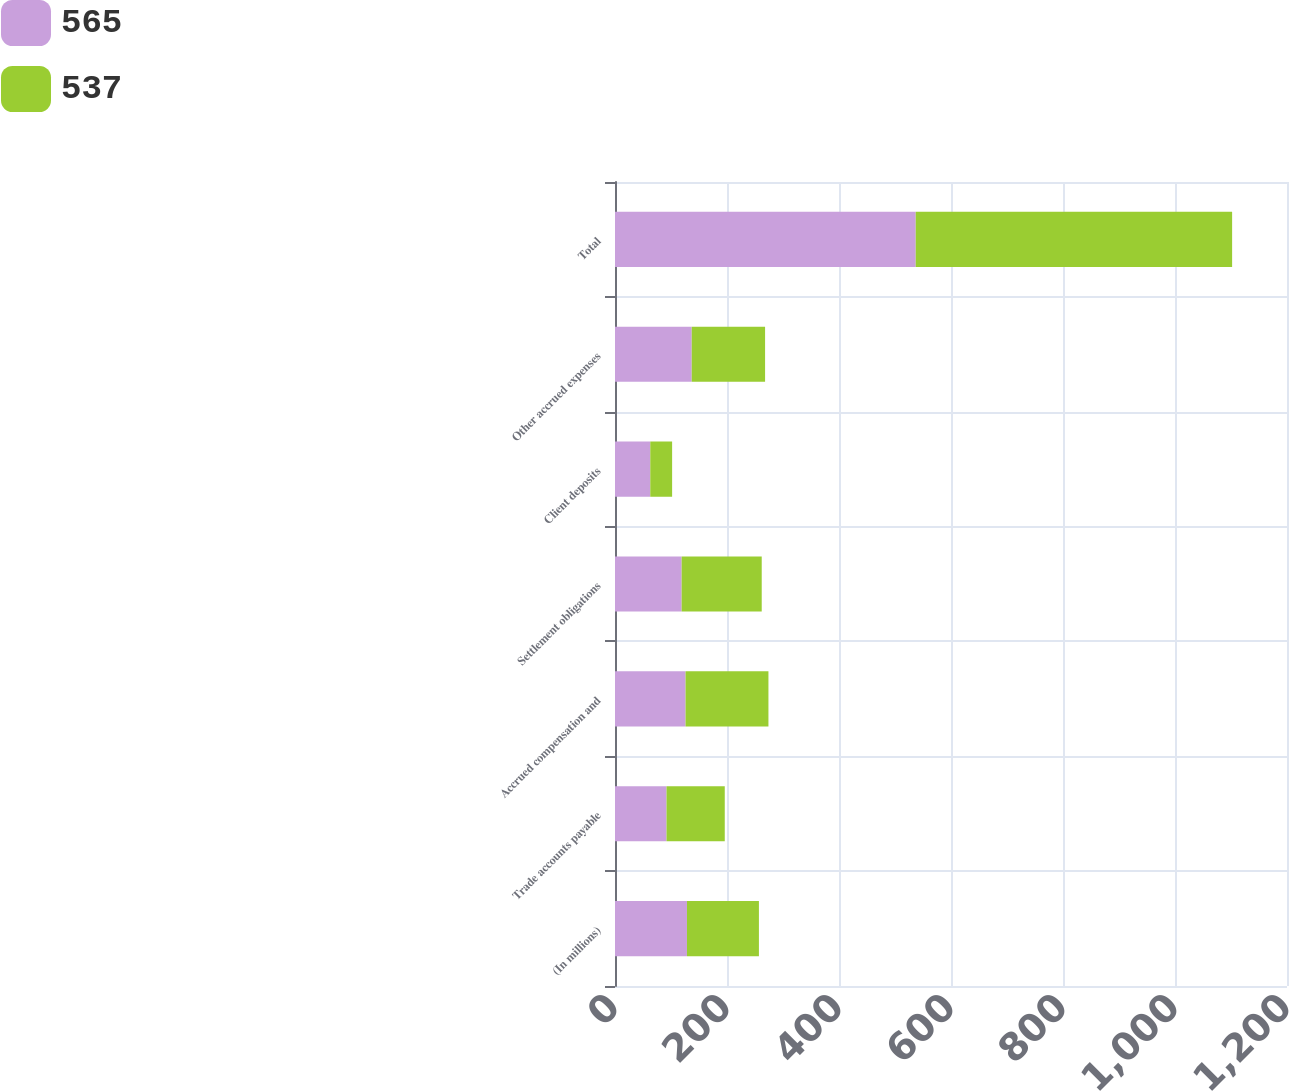Convert chart to OTSL. <chart><loc_0><loc_0><loc_500><loc_500><stacked_bar_chart><ecel><fcel>(In millions)<fcel>Trade accounts payable<fcel>Accrued compensation and<fcel>Settlement obligations<fcel>Client deposits<fcel>Other accrued expenses<fcel>Total<nl><fcel>565<fcel>128.5<fcel>92<fcel>126<fcel>119<fcel>63<fcel>137<fcel>537<nl><fcel>537<fcel>128.5<fcel>104<fcel>148<fcel>143<fcel>39<fcel>131<fcel>565<nl></chart> 